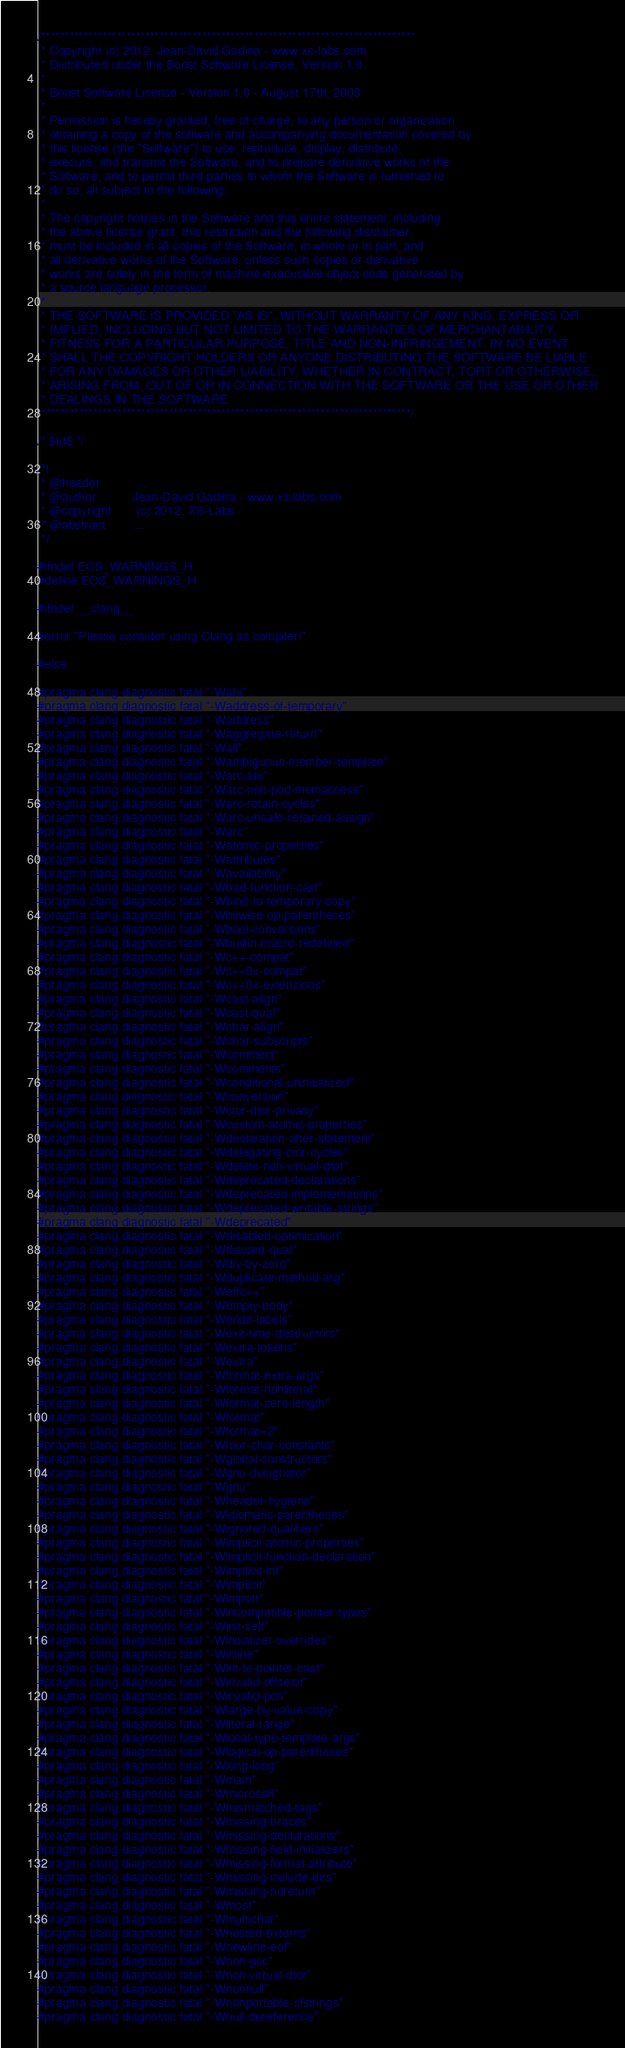<code> <loc_0><loc_0><loc_500><loc_500><_C_>/*******************************************************************************
 * Copyright (c) 2012, Jean-David Gadina - www.xs-labs.com
 * Distributed under the Boost Software License, Version 1.0.
 * 
 * Boost Software License - Version 1.0 - August 17th, 2003
 * 
 * Permission is hereby granted, free of charge, to any person or organization
 * obtaining a copy of the software and accompanying documentation covered by
 * this license (the "Software") to use, reproduce, display, distribute,
 * execute, and transmit the Software, and to prepare derivative works of the
 * Software, and to permit third-parties to whom the Software is furnished to
 * do so, all subject to the following:
 * 
 * The copyright notices in the Software and this entire statement, including
 * the above license grant, this restriction and the following disclaimer,
 * must be included in all copies of the Software, in whole or in part, and
 * all derivative works of the Software, unless such copies or derivative
 * works are solely in the form of machine-executable object code generated by
 * a source language processor.
 * 
 * THE SOFTWARE IS PROVIDED "AS IS", WITHOUT WARRANTY OF ANY KIND, EXPRESS OR
 * IMPLIED, INCLUDING BUT NOT LIMITED TO THE WARRANTIES OF MERCHANTABILITY,
 * FITNESS FOR A PARTICULAR PURPOSE, TITLE AND NON-INFRINGEMENT. IN NO EVENT
 * SHALL THE COPYRIGHT HOLDERS OR ANYONE DISTRIBUTING THE SOFTWARE BE LIABLE
 * FOR ANY DAMAGES OR OTHER LIABILITY, WHETHER IN CONTRACT, TORT OR OTHERWISE,
 * ARISING FROM, OUT OF OR IN CONNECTION WITH THE SOFTWARE OR THE USE OR OTHER
 * DEALINGS IN THE SOFTWARE.
 ******************************************************************************/

/* $Id$ */

/*!
 * @header          ...
 * @author          Jean-David Gadina - www.xs-labs.com
 * @copyright       (c) 2012, XS-Labs
 * @abstract        ...
 */

#ifndef EOS_WARNINGS_H
#define EOS_WARNINGS_H

#ifndef __clang__

#error "Please consider using Clang as compiler!"

#else

#pragma clang diagnostic fatal "-Wabi"
#pragma clang diagnostic fatal "-Waddress-of-temporary"
#pragma clang diagnostic fatal "-Waddress"
#pragma clang diagnostic fatal "-Waggregate-return"
#pragma clang diagnostic fatal "-Wall"
#pragma clang diagnostic fatal "-Wambiguous-member-template"
#pragma clang diagnostic fatal "-Warc-abi"
#pragma clang diagnostic fatal "-Warc-non-pod-memaccess"
#pragma clang diagnostic fatal "-Warc-retain-cycles"
#pragma clang diagnostic fatal "-Warc-unsafe-retained-assign"
#pragma clang diagnostic fatal "-Warc"
#pragma clang diagnostic fatal "-Watomic-properties"
#pragma clang diagnostic fatal "-Wattributes"
#pragma clang diagnostic fatal "-Wavailability"
#pragma clang diagnostic fatal "-Wbad-function-cast"
#pragma clang diagnostic fatal "-Wbind-to-temporary-copy"
#pragma clang diagnostic fatal "-Wbitwise-op-parentheses"
#pragma clang diagnostic fatal "-Wbool-conversions"
#pragma clang diagnostic fatal "-Wbuiltin-macro-redefined"
#pragma clang diagnostic fatal "-Wc++-compat"
#pragma clang diagnostic fatal "-Wc++0x-compat"
#pragma clang diagnostic fatal "-Wc++0x-extensions"
#pragma clang diagnostic fatal "-Wcast-align"
#pragma clang diagnostic fatal "-Wcast-qual"
#pragma clang diagnostic fatal "-Wchar-align"
#pragma clang diagnostic fatal "-Wchar-subscripts"
#pragma clang diagnostic fatal "-Wcomment"
#pragma clang diagnostic fatal "-Wcomments"
#pragma clang diagnostic fatal "-Wconditional-uninitialized"
#pragma clang diagnostic fatal "-Wconversion"
#pragma clang diagnostic fatal "-Wctor-dtor-privacy"
#pragma clang diagnostic fatal "-Wcustom-atomic-properties"
#pragma clang diagnostic fatal "-Wdeclaration-after-statement"
#pragma clang diagnostic fatal "-Wdelegating-ctor-cycles"
#pragma clang diagnostic fatal "-Wdelete-non-virtual-dtor"
#pragma clang diagnostic fatal "-Wdeprecated-declarations"
#pragma clang diagnostic fatal "-Wdeprecated-implementations"
#pragma clang diagnostic fatal "-Wdeprecated-writable-strings"
#pragma clang diagnostic fatal "-Wdeprecated"
#pragma clang diagnostic fatal "-Wdisabled-optimization"
#pragma clang diagnostic fatal "-Wdiscard-qual"
#pragma clang diagnostic fatal "-Wdiv-by-zero"
#pragma clang diagnostic fatal "-Wduplicate-method-arg"
#pragma clang diagnostic fatal "-Weffc++"
#pragma clang diagnostic fatal "-Wempty-body"
#pragma clang diagnostic fatal "-Wendif-labels"
#pragma clang diagnostic fatal "-Wexit-time-destructors"
#pragma clang diagnostic fatal "-Wextra-tokens"
#pragma clang diagnostic fatal "-Wextra"
#pragma clang diagnostic fatal "-Wformat-extra-args"
#pragma clang diagnostic fatal "-Wformat-nonliteral"
#pragma clang diagnostic fatal "-Wformat-zero-length"
#pragma clang diagnostic fatal "-Wformat"
#pragma clang diagnostic fatal "-Wformat=2"
#pragma clang diagnostic fatal "-Wfour-char-constants"
#pragma clang diagnostic fatal "-Wglobal-constructors"
#pragma clang diagnostic fatal "-Wgnu-designator"
#pragma clang diagnostic fatal "-Wgnu"
#pragma clang diagnostic fatal "-Wheader-hygiene"
#pragma clang diagnostic fatal "-Widiomatic-parentheses"
#pragma clang diagnostic fatal "-Wignored-qualifiers"
#pragma clang diagnostic fatal "-Wimplicit-atomic-properties"
#pragma clang diagnostic fatal "-Wimplicit-function-declaration"
#pragma clang diagnostic fatal "-Wimplicit-int"
#pragma clang diagnostic fatal "-Wimplicit"
#pragma clang diagnostic fatal "-Wimport"
#pragma clang diagnostic fatal "-Wincompatible-pointer-types"
#pragma clang diagnostic fatal "-Winit-self"
#pragma clang diagnostic fatal "-Winitializer-overrides"
#pragma clang diagnostic fatal "-Winline"
#pragma clang diagnostic fatal "-Wint-to-pointer-cast"
#pragma clang diagnostic fatal "-Winvalid-offsetof"
#pragma clang diagnostic fatal "-Winvalid-pch"
#pragma clang diagnostic fatal "-Wlarge-by-value-copy"
#pragma clang diagnostic fatal "-Wliteral-range"
#pragma clang diagnostic fatal "-Wlocal-type-template-args"
#pragma clang diagnostic fatal "-Wlogical-op-parentheses"
#pragma clang diagnostic fatal "-Wlong-long"
#pragma clang diagnostic fatal "-Wmain"
#pragma clang diagnostic fatal "-Wmicrosoft"
#pragma clang diagnostic fatal "-Wmismatched-tags"
#pragma clang diagnostic fatal "-Wmissing-braces"
#pragma clang diagnostic fatal "-Wmissing-declarations"
#pragma clang diagnostic fatal "-Wmissing-field-initializers"
#pragma clang diagnostic fatal "-Wmissing-format-attribute"
#pragma clang diagnostic fatal "-Wmissing-include-dirs"
#pragma clang diagnostic fatal "-Wmissing-noreturn"
#pragma clang diagnostic fatal "-Wmost"
#pragma clang diagnostic fatal "-Wmultichar"
#pragma clang diagnostic fatal "-Wnested-externs"
#pragma clang diagnostic fatal "-Wnewline-eof"
#pragma clang diagnostic fatal "-Wnon-gcc"
#pragma clang diagnostic fatal "-Wnon-virtual-dtor"
#pragma clang diagnostic fatal "-Wnonnull"
#pragma clang diagnostic fatal "-Wnonportable-cfstrings"
#pragma clang diagnostic fatal "-Wnull-dereference"</code> 